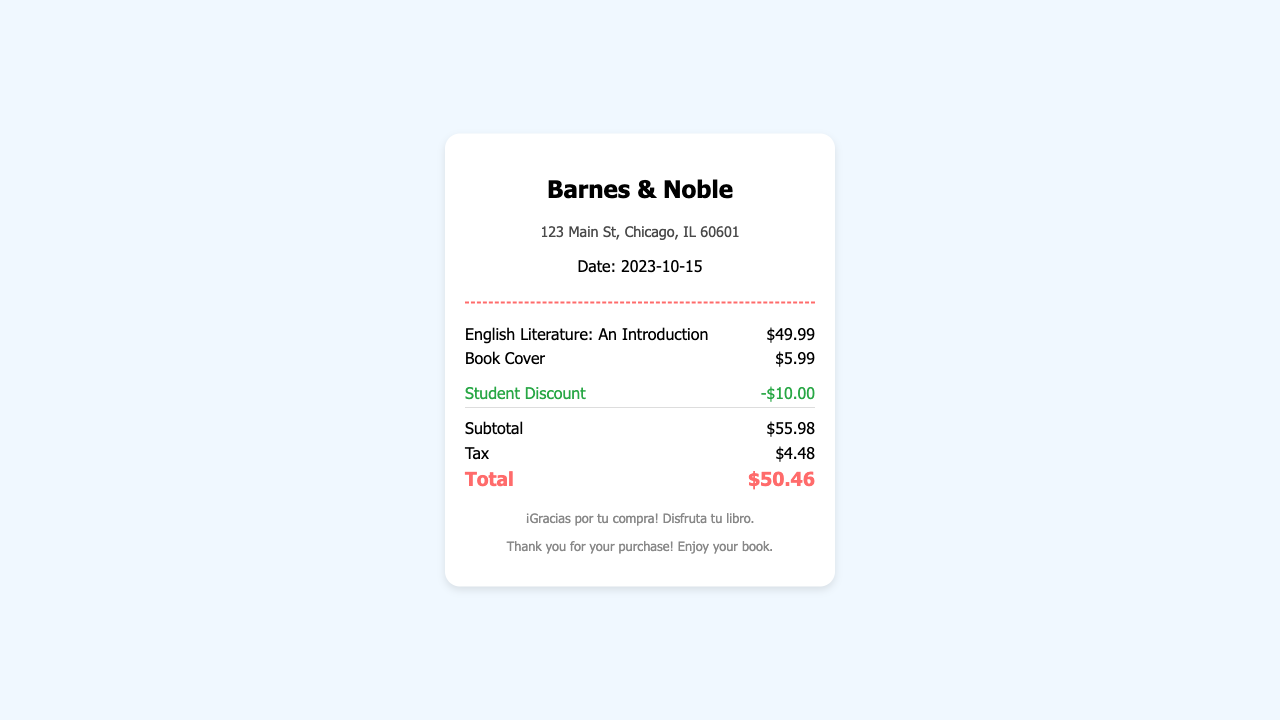What is the name of the bookstore? The name of the bookstore is displayed at the top of the document.
Answer: Barnes & Noble What is the purchase date? The purchase date is shown below the store information.
Answer: 2023-10-15 What is the price of the textbook? The price of the textbook is listed next to its title in the items section.
Answer: $49.99 What is the amount of the student discount? The discount is shown in the discount section and is a negative value.
Answer: -$10.00 What is the subtotal before tax? The subtotal is mentioned in the totals section.
Answer: $55.98 What is the total amount after tax? The total is calculated after adding tax to the subtotal and is presented at the bottom.
Answer: $50.46 How much tax was applied? The tax amount is listed in the totals section of the document.
Answer: $4.48 What is included with the textbook purchase? The items purchased are displayed in the items section.
Answer: Book Cover What information is included in the store information? The store information consists of the store name and address.
Answer: 123 Main St, Chicago, IL 60601 What message is shown at the bottom of the receipt? The footer contains a thank you message for the purchase.
Answer: ¡Gracias por tu compra! Disfruta tu libro 